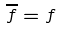<formula> <loc_0><loc_0><loc_500><loc_500>\overline { f } = f</formula> 